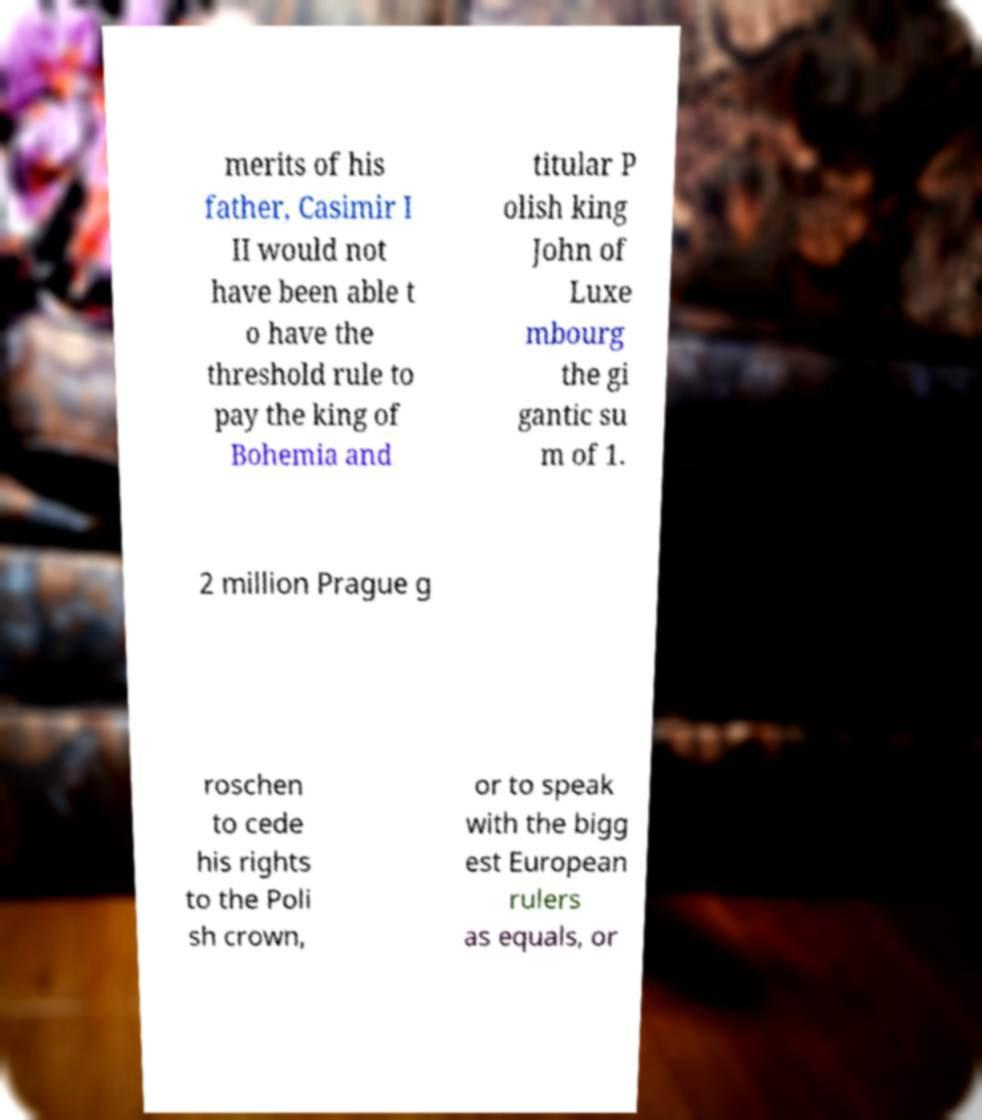Please read and relay the text visible in this image. What does it say? merits of his father, Casimir I II would not have been able t o have the threshold rule to pay the king of Bohemia and titular P olish king John of Luxe mbourg the gi gantic su m of 1. 2 million Prague g roschen to cede his rights to the Poli sh crown, or to speak with the bigg est European rulers as equals, or 